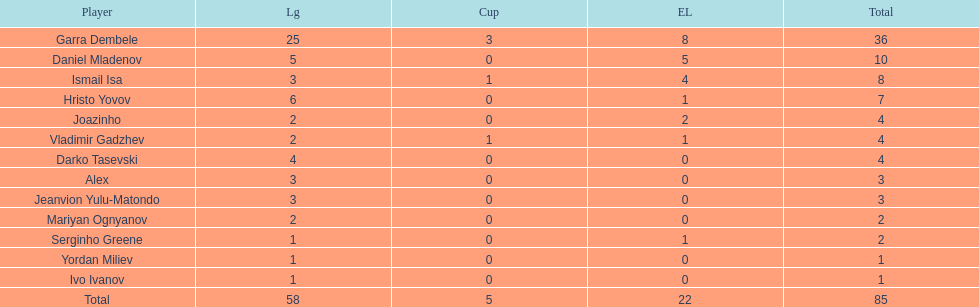Which total is higher, the europa league total or the league total? League. 